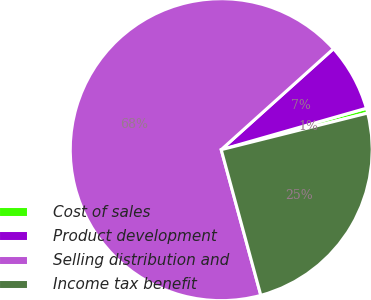Convert chart to OTSL. <chart><loc_0><loc_0><loc_500><loc_500><pie_chart><fcel>Cost of sales<fcel>Product development<fcel>Selling distribution and<fcel>Income tax benefit<nl><fcel>0.53%<fcel>7.23%<fcel>67.57%<fcel>24.67%<nl></chart> 